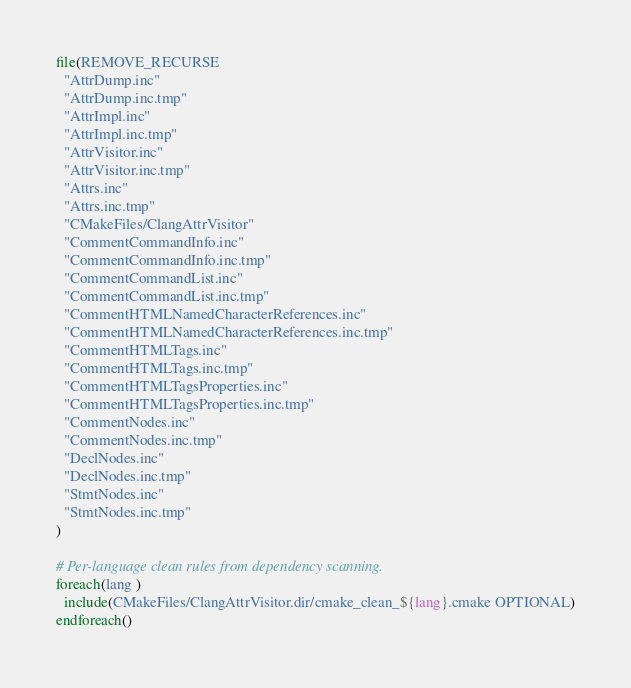<code> <loc_0><loc_0><loc_500><loc_500><_CMake_>file(REMOVE_RECURSE
  "AttrDump.inc"
  "AttrDump.inc.tmp"
  "AttrImpl.inc"
  "AttrImpl.inc.tmp"
  "AttrVisitor.inc"
  "AttrVisitor.inc.tmp"
  "Attrs.inc"
  "Attrs.inc.tmp"
  "CMakeFiles/ClangAttrVisitor"
  "CommentCommandInfo.inc"
  "CommentCommandInfo.inc.tmp"
  "CommentCommandList.inc"
  "CommentCommandList.inc.tmp"
  "CommentHTMLNamedCharacterReferences.inc"
  "CommentHTMLNamedCharacterReferences.inc.tmp"
  "CommentHTMLTags.inc"
  "CommentHTMLTags.inc.tmp"
  "CommentHTMLTagsProperties.inc"
  "CommentHTMLTagsProperties.inc.tmp"
  "CommentNodes.inc"
  "CommentNodes.inc.tmp"
  "DeclNodes.inc"
  "DeclNodes.inc.tmp"
  "StmtNodes.inc"
  "StmtNodes.inc.tmp"
)

# Per-language clean rules from dependency scanning.
foreach(lang )
  include(CMakeFiles/ClangAttrVisitor.dir/cmake_clean_${lang}.cmake OPTIONAL)
endforeach()
</code> 